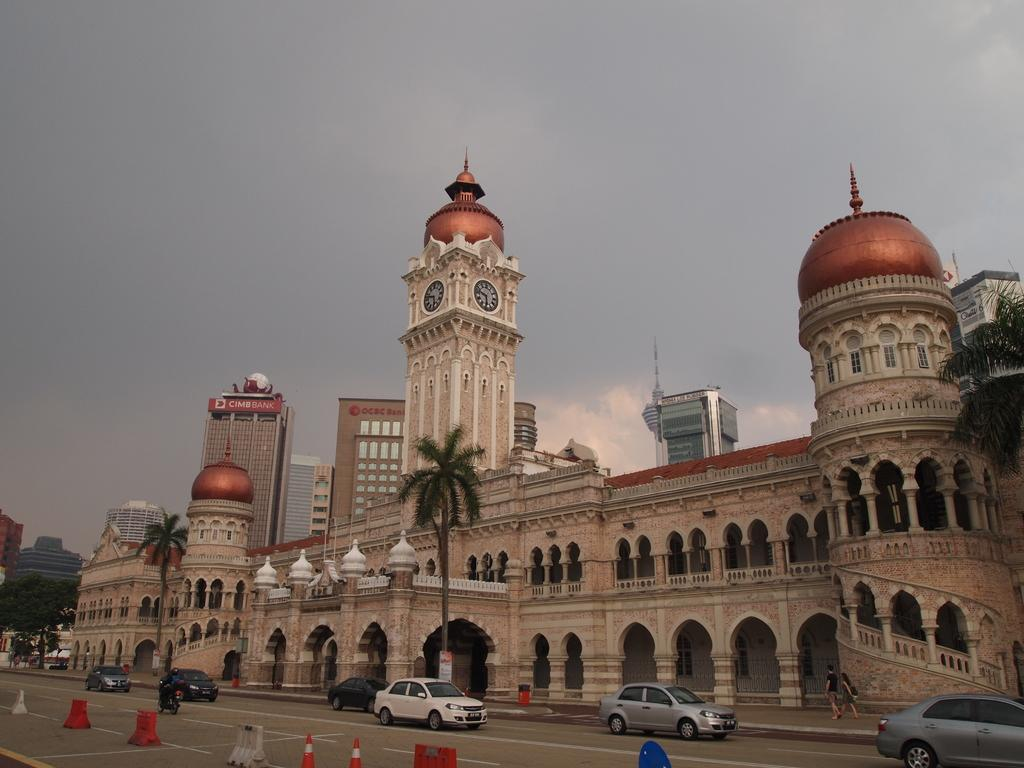What type of vehicles can be seen on the road in the image? There are cars on the road in the image. What objects are placed on the road to guide or warn drivers? Traffic cones are present on the road. What type of building is visible in the image? There is a palace in the image. What type of vegetation is in front of the palace? Trees are in front of the palace. What is visible in the sky in the image? The sky is visible in the image, and clouds are present in the sky. How many brothers are sitting at the desk in the image? There is no desk or brothers present in the image. What type of frogs can be seen jumping around the palace in the image? There are no frogs present in the image; it features cars on the road, traffic cones, a palace, trees, and a sky with clouds. 